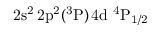Convert formula to latex. <formula><loc_0><loc_0><loc_500><loc_500>2 s ^ { 2 } \, 2 p ^ { 2 } ( ^ { 3 } P ) \, 4 d ^ { 4 } P _ { 1 / 2 }</formula> 